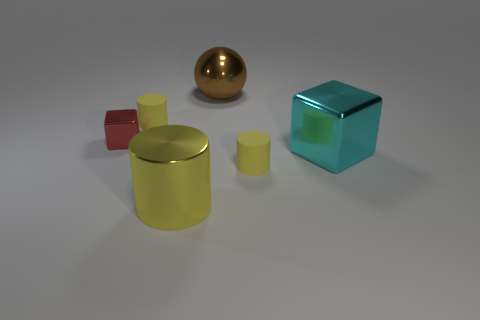How many other things are the same color as the large block?
Give a very brief answer. 0. There is a yellow thing that is to the right of the sphere; is its size the same as the tiny red shiny thing?
Keep it short and to the point. Yes. What material is the cylinder to the right of the large brown sphere?
Offer a terse response. Rubber. Is there anything else that is the same shape as the big brown object?
Offer a terse response. No. How many matte things are either green cylinders or cyan things?
Give a very brief answer. 0. Are there fewer large brown things on the right side of the sphere than big green balls?
Give a very brief answer. No. The yellow matte thing that is behind the tiny yellow object that is to the right of the rubber cylinder behind the small red block is what shape?
Your answer should be compact. Cylinder. Is the number of brown metallic objects greater than the number of rubber cylinders?
Provide a succinct answer. No. How many other objects are there of the same material as the large yellow cylinder?
Your response must be concise. 3. How many things are large cyan blocks or shiny objects in front of the tiny shiny object?
Provide a succinct answer. 2. 